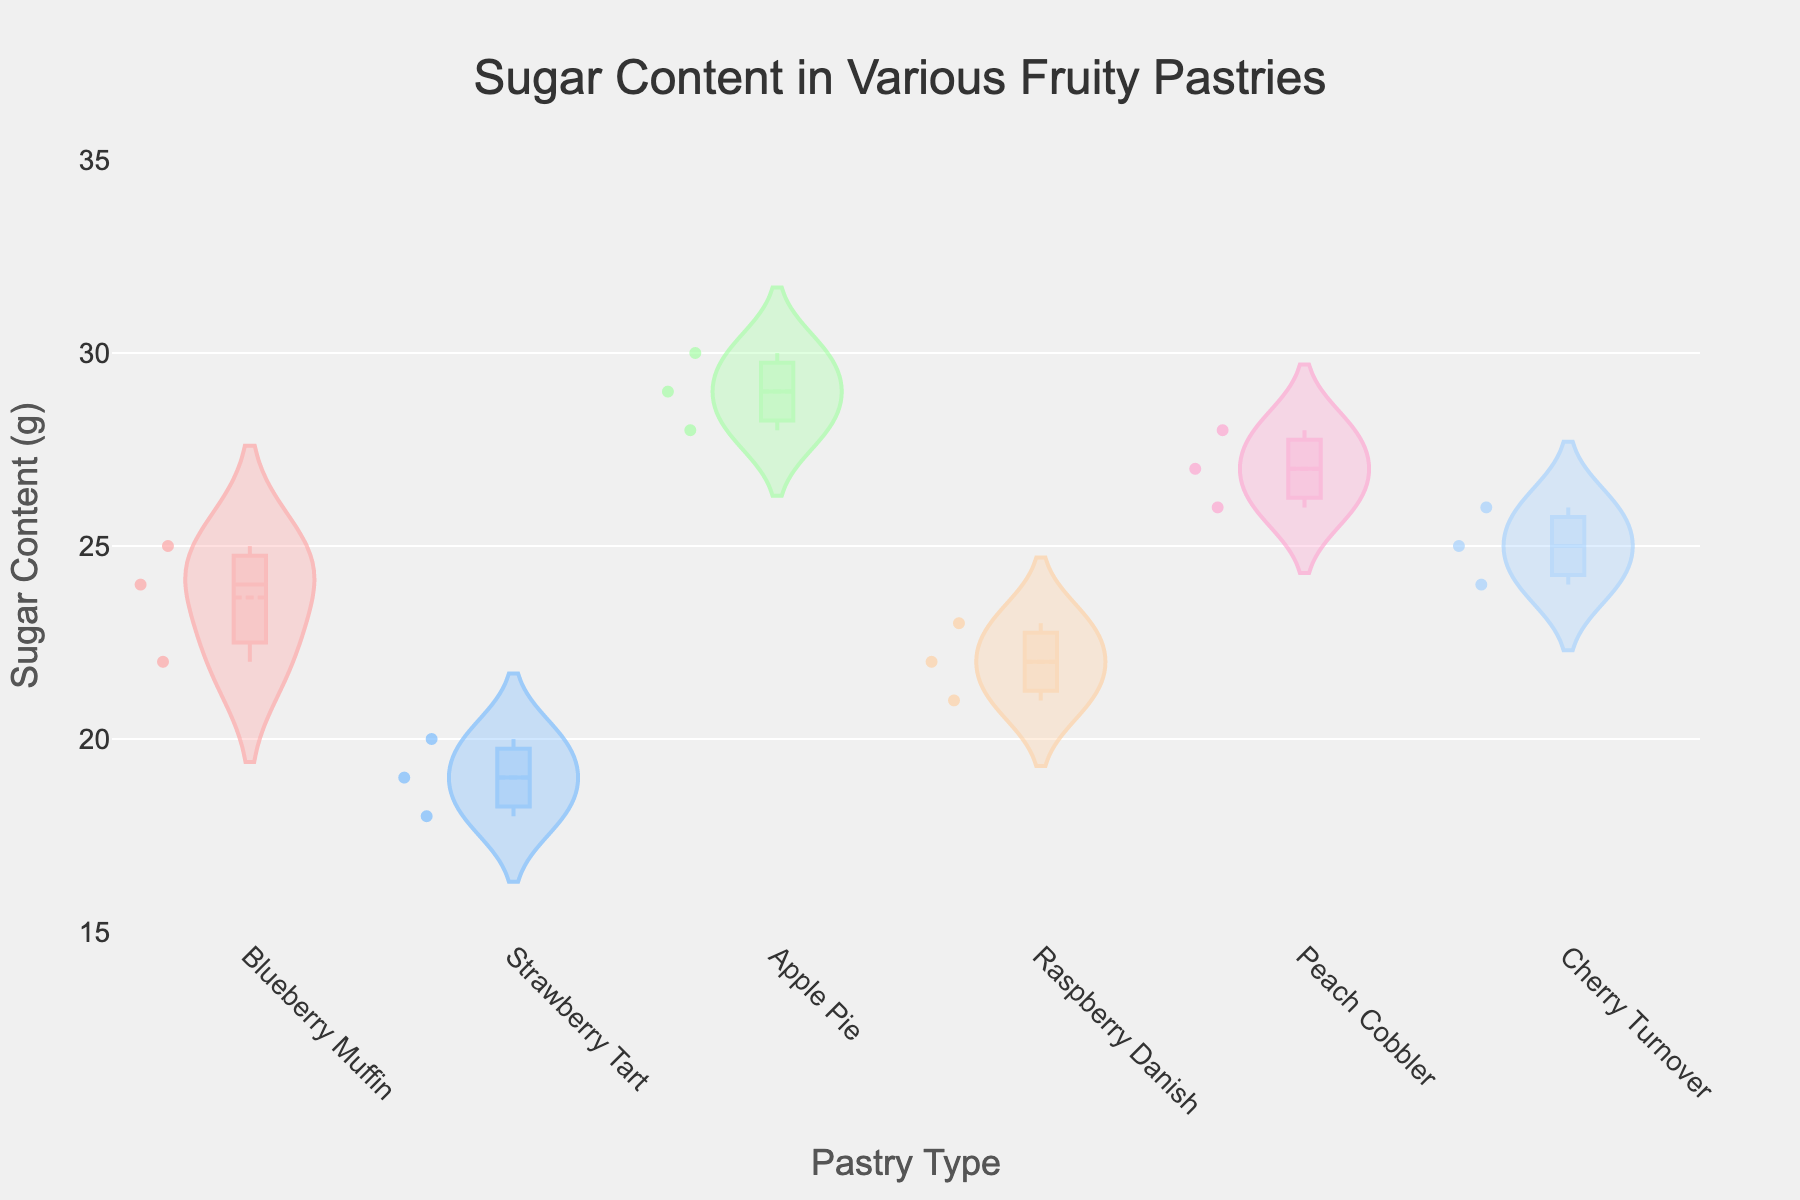What is the title of the figure? The title of the figure is typically displayed at the top of the plot, and in this case, it says "Sugar Content in Various Fruity Pastries".
Answer: Sugar Content in Various Fruity Pastries Which pastry has the highest median sugar content? Look at the median lines inside the box plots of each violin plot. The Apple Pie has the highest median line among all the pastries.
Answer: Apple Pie How many different pastry types are displayed in the figure? Count the unique pastry names along the x-axis, which represent each category of the violin plots. There are six different pastry types displayed.
Answer: Six Which bakery's Blueberry Muffin has the highest sugar content? Refer to the individual data points within the Blueberry Muffin violin plot. The highest point is associated with French Delicacies, which has the maximum sugar content for Blueberry Muffin.
Answer: French Delicacies What is the range of sugar content for Strawberry Tart? The range is the difference between the highest and lowest values within the Strawberry Tart violin plot. From the data, the highest is 20 and the lowest is 18. Therefore, the range is 20 - 18 = 2.
Answer: 2 grams Which two pastries have overlapping sugar content ranges? Overlapping ranges can be observed where the violin plots intersect. Raspberry Danish and Cherry Turnover have overlapping ranges, as their data points and distribution regions are closely aligned.
Answer: Raspberry Danish and Cherry Turnover What is the mean sugar content for Peach Cobbler? The mean is indicated by a line within each violin plot. Observe the mean line position within the Peach Cobbler's plot. The mean sugar content is close to 27 grams.
Answer: 27 grams Do any pastries have outliers in their sugar content? Outliers, if present, would typically be indicated by isolated points outside the main body of the distribution. No isolated points are visible outside the violin plots for any of the pastries, indicating no outliers.
Answer: No Which bakery's Apple Pie has the lowest sugar content? Check the lowest data point within the Apple Pie violin plot. French Delicacies has the lowest value for Apple Pie at 28 grams.
Answer: French Delicacies Approximately how many grams of sugar content does Cherry Turnover from Pastry Perfection contain? Look at the data points within the Cherry Turnover violin plot. The data point that lies on the Pastry Perfection trace is at 24 grams.
Answer: 24 grams 